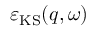<formula> <loc_0><loc_0><loc_500><loc_500>\varepsilon _ { K S } ( q , \omega )</formula> 